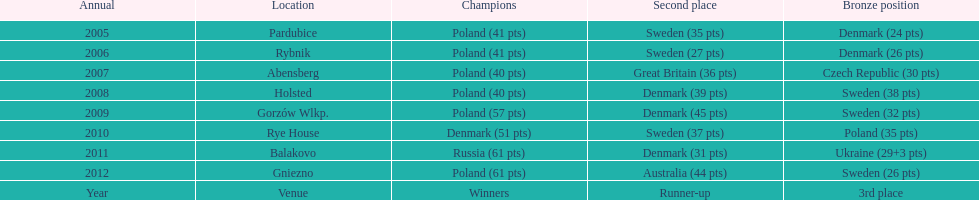Would you be able to parse every entry in this table? {'header': ['Annual', 'Location', 'Champions', 'Second place', 'Bronze position'], 'rows': [['2005', 'Pardubice', 'Poland (41 pts)', 'Sweden (35 pts)', 'Denmark (24 pts)'], ['2006', 'Rybnik', 'Poland (41 pts)', 'Sweden (27 pts)', 'Denmark (26 pts)'], ['2007', 'Abensberg', 'Poland (40 pts)', 'Great Britain (36 pts)', 'Czech Republic (30 pts)'], ['2008', 'Holsted', 'Poland (40 pts)', 'Denmark (39 pts)', 'Sweden (38 pts)'], ['2009', 'Gorzów Wlkp.', 'Poland (57 pts)', 'Denmark (45 pts)', 'Sweden (32 pts)'], ['2010', 'Rye House', 'Denmark (51 pts)', 'Sweden (37 pts)', 'Poland (35 pts)'], ['2011', 'Balakovo', 'Russia (61 pts)', 'Denmark (31 pts)', 'Ukraine (29+3 pts)'], ['2012', 'Gniezno', 'Poland (61 pts)', 'Australia (44 pts)', 'Sweden (26 pts)'], ['Year', 'Venue', 'Winners', 'Runner-up', '3rd place']]} What is the total number of points earned in the years 2009? 134. 